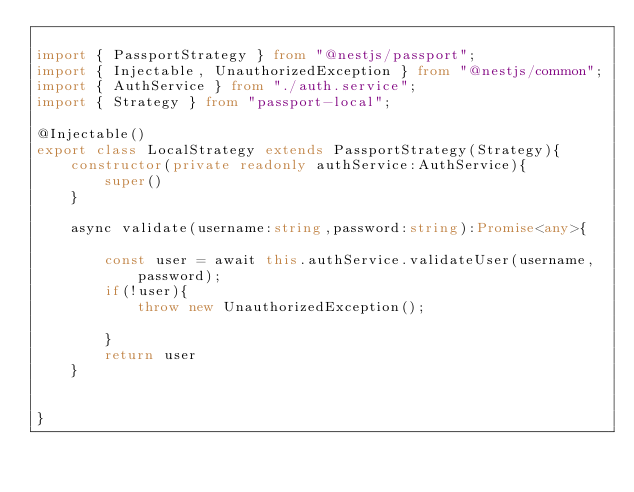<code> <loc_0><loc_0><loc_500><loc_500><_TypeScript_>
import { PassportStrategy } from "@nestjs/passport";
import { Injectable, UnauthorizedException } from "@nestjs/common";
import { AuthService } from "./auth.service";
import { Strategy } from "passport-local";

@Injectable()
export class LocalStrategy extends PassportStrategy(Strategy){
    constructor(private readonly authService:AuthService){
        super()
    }

    async validate(username:string,password:string):Promise<any>{

        const user = await this.authService.validateUser(username,password);
        if(!user){
            throw new UnauthorizedException();

        }
        return user
    }


}</code> 